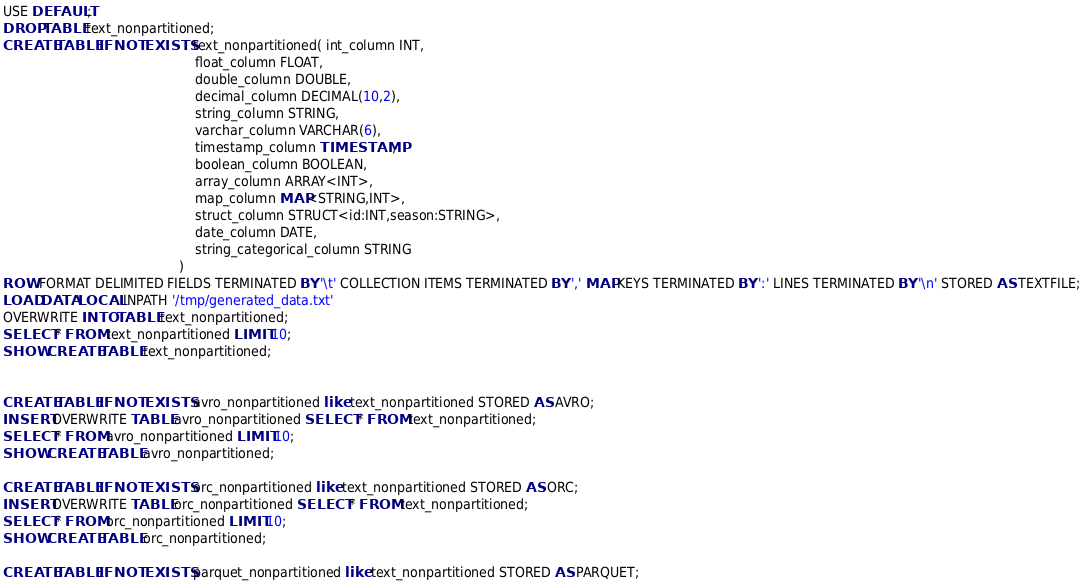<code> <loc_0><loc_0><loc_500><loc_500><_SQL_>USE DEFAULT;
DROP TABLE text_nonpartitioned;
CREATE TABLE IF NOT EXISTS text_nonpartitioned( int_column INT,
                                                float_column FLOAT,
                                                double_column DOUBLE,
                                                decimal_column DECIMAL(10,2),
                                                string_column STRING,
                                                varchar_column VARCHAR(6),
                                                timestamp_column TIMESTAMP,
                                                boolean_column BOOLEAN,
                                                array_column ARRAY<INT>,
                                                map_column MAP<STRING,INT>,
                                                struct_column STRUCT<id:INT,season:STRING>,
                                                date_column DATE,
                                                string_categorical_column STRING
                                            )
ROW FORMAT DELIMITED FIELDS TERMINATED BY '\t' COLLECTION ITEMS TERMINATED BY ',' MAP KEYS TERMINATED BY ':' LINES TERMINATED BY '\n' STORED AS TEXTFILE;
LOAD DATA LOCAL INPATH '/tmp/generated_data.txt'
OVERWRITE INTO TABLE text_nonpartitioned;
SELECT * FROM text_nonpartitioned LIMIT 10;
SHOW CREATE TABLE text_nonpartitioned;


CREATE TABLE IF NOT EXISTS avro_nonpartitioned like text_nonpartitioned STORED AS AVRO;
INSERT OVERWRITE TABLE avro_nonpartitioned SELECT * FROM text_nonpartitioned;
SELECT * FROM avro_nonpartitioned LIMIT 10;
SHOW CREATE TABLE avro_nonpartitioned;

CREATE TABLE IF NOT EXISTS orc_nonpartitioned like text_nonpartitioned STORED AS ORC;
INSERT OVERWRITE TABLE orc_nonpartitioned SELECT * FROM text_nonpartitioned;
SELECT * FROM orc_nonpartitioned LIMIT 10;
SHOW CREATE TABLE orc_nonpartitioned;

CREATE TABLE IF NOT EXISTS parquet_nonpartitioned like text_nonpartitioned STORED AS PARQUET;</code> 